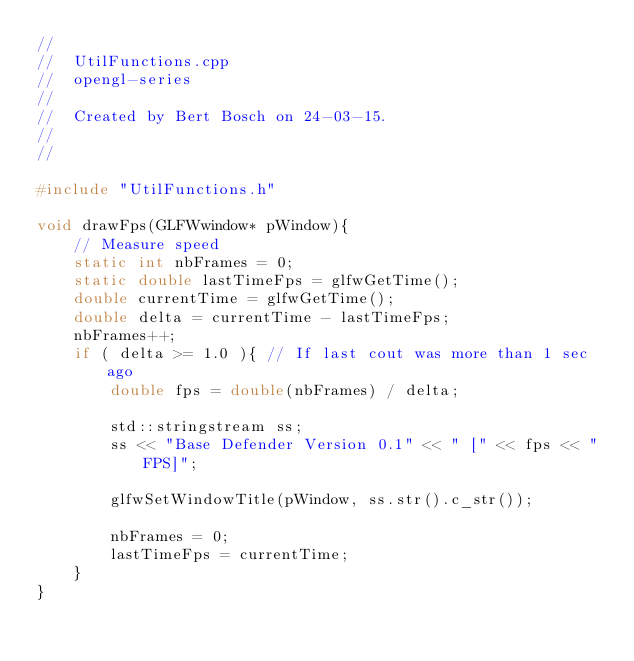<code> <loc_0><loc_0><loc_500><loc_500><_C++_>//
//  UtilFunctions.cpp
//  opengl-series
//
//  Created by Bert Bosch on 24-03-15.
//
//

#include "UtilFunctions.h"

void drawFps(GLFWwindow* pWindow){
    // Measure speed
    static int nbFrames = 0;
    static double lastTimeFps = glfwGetTime();
    double currentTime = glfwGetTime();
    double delta = currentTime - lastTimeFps;
    nbFrames++;
    if ( delta >= 1.0 ){ // If last cout was more than 1 sec ago
        double fps = double(nbFrames) / delta;
        
        std::stringstream ss;
        ss << "Base Defender Version 0.1" << " [" << fps << " FPS]";
        
        glfwSetWindowTitle(pWindow, ss.str().c_str());
        
        nbFrames = 0;
        lastTimeFps = currentTime;
    }
}</code> 